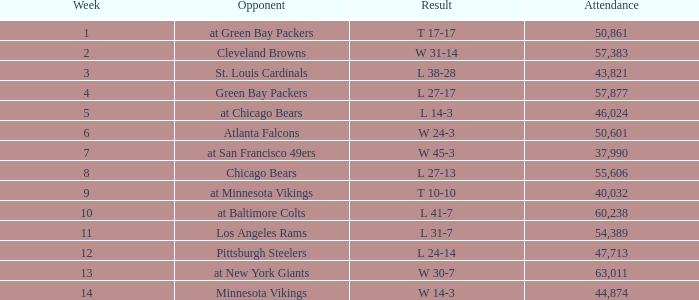How many weeks have a Result of t 10-10? 1.0. 